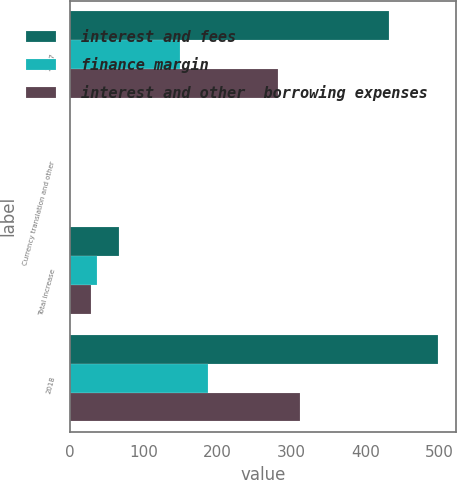Convert chart. <chart><loc_0><loc_0><loc_500><loc_500><stacked_bar_chart><ecel><fcel>2017<fcel>Currency translation and other<fcel>Total increase<fcel>2018<nl><fcel>interest and fees<fcel>431.1<fcel>0.5<fcel>66.6<fcel>497.7<nl><fcel>finance margin<fcel>149.6<fcel>0.1<fcel>37.3<fcel>186.9<nl><fcel>interest and other  borrowing expenses<fcel>281.5<fcel>0.6<fcel>29.3<fcel>310.8<nl></chart> 